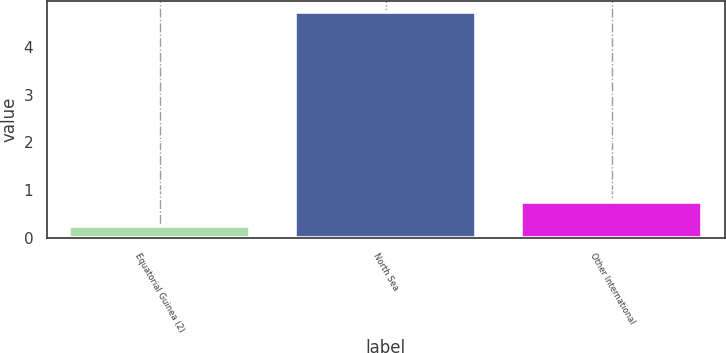Convert chart. <chart><loc_0><loc_0><loc_500><loc_500><bar_chart><fcel>Equatorial Guinea (2)<fcel>North Sea<fcel>Other International<nl><fcel>0.25<fcel>4.73<fcel>0.75<nl></chart> 